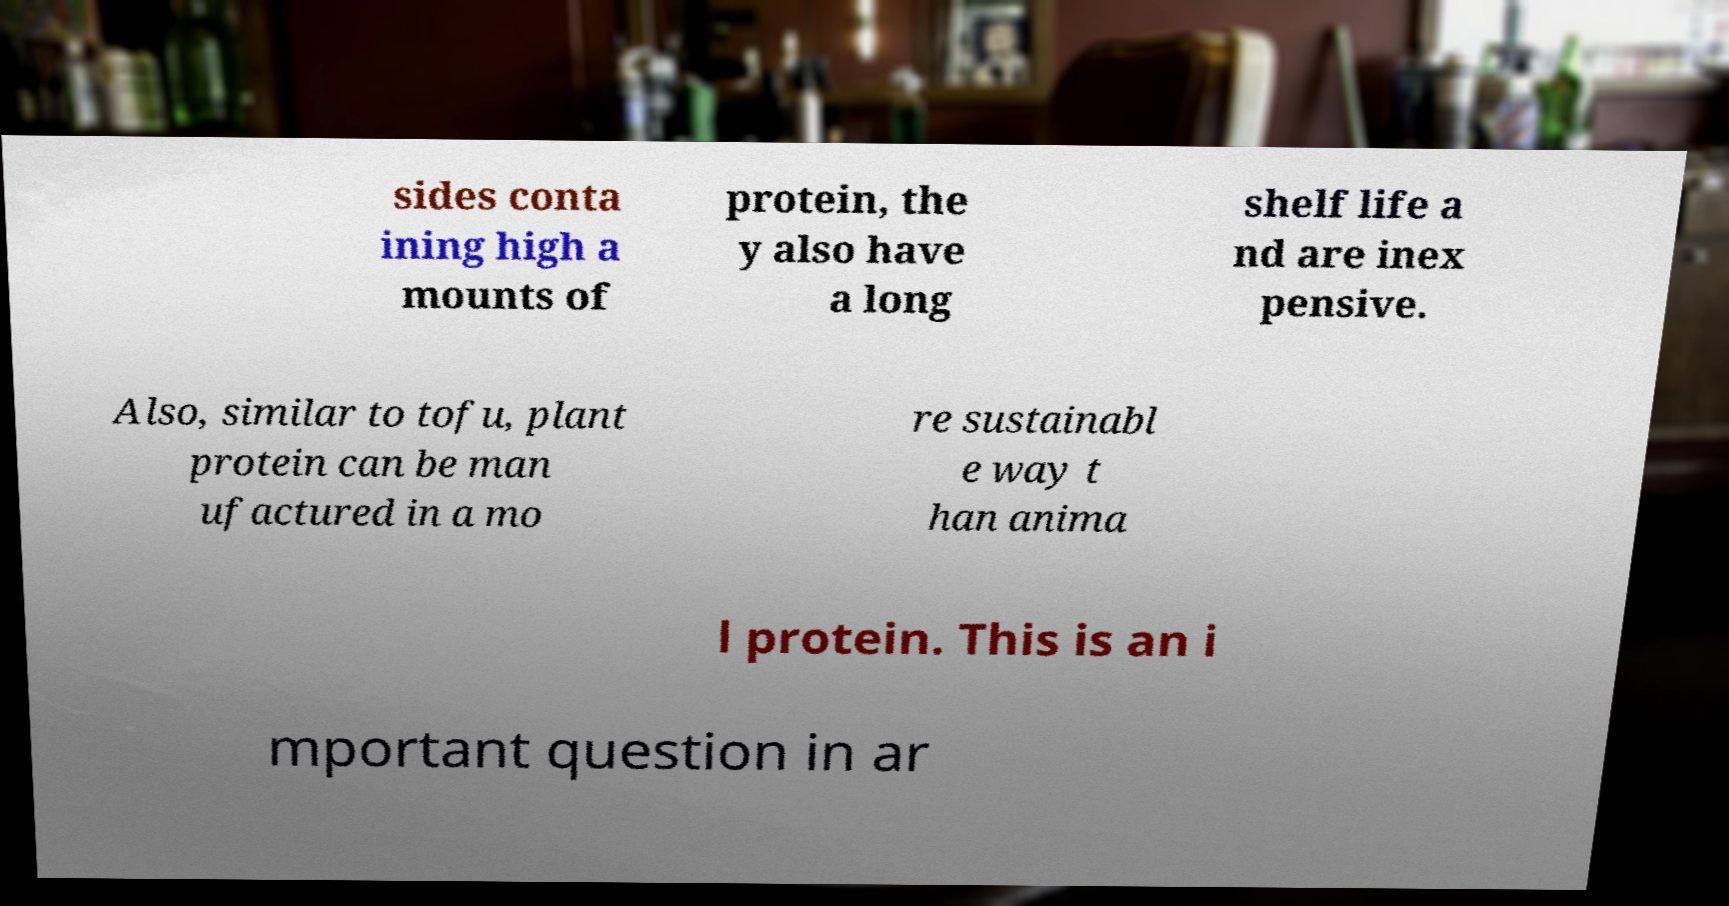Could you extract and type out the text from this image? sides conta ining high a mounts of protein, the y also have a long shelf life a nd are inex pensive. Also, similar to tofu, plant protein can be man ufactured in a mo re sustainabl e way t han anima l protein. This is an i mportant question in ar 